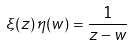<formula> <loc_0><loc_0><loc_500><loc_500>\xi ( z ) \, \eta ( w ) = \frac { 1 } { z - w } \,</formula> 